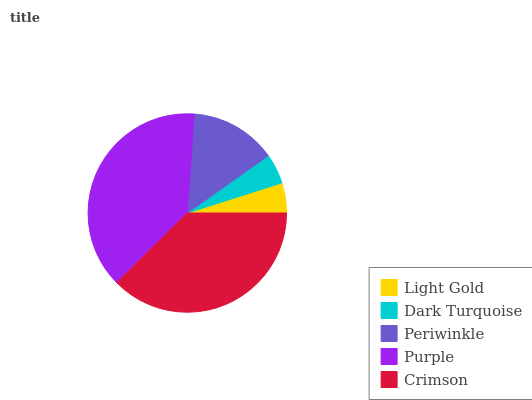Is Dark Turquoise the minimum?
Answer yes or no. Yes. Is Purple the maximum?
Answer yes or no. Yes. Is Periwinkle the minimum?
Answer yes or no. No. Is Periwinkle the maximum?
Answer yes or no. No. Is Periwinkle greater than Dark Turquoise?
Answer yes or no. Yes. Is Dark Turquoise less than Periwinkle?
Answer yes or no. Yes. Is Dark Turquoise greater than Periwinkle?
Answer yes or no. No. Is Periwinkle less than Dark Turquoise?
Answer yes or no. No. Is Periwinkle the high median?
Answer yes or no. Yes. Is Periwinkle the low median?
Answer yes or no. Yes. Is Purple the high median?
Answer yes or no. No. Is Light Gold the low median?
Answer yes or no. No. 